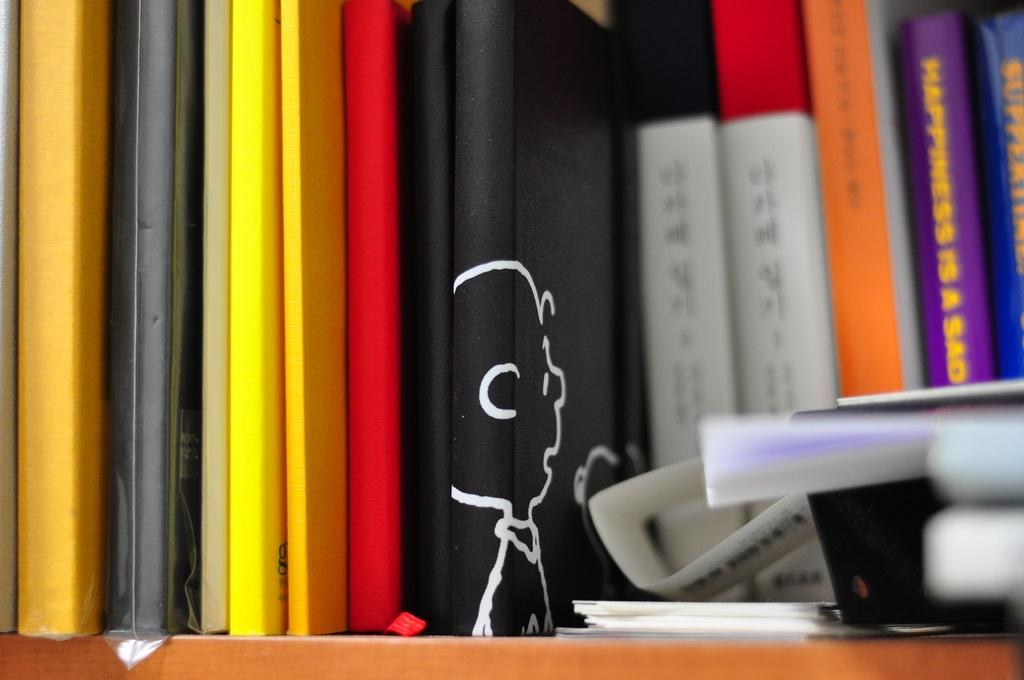<image>
Share a concise interpretation of the image provided. A collection of books varying in color with one of them being Happiness is a Sad 